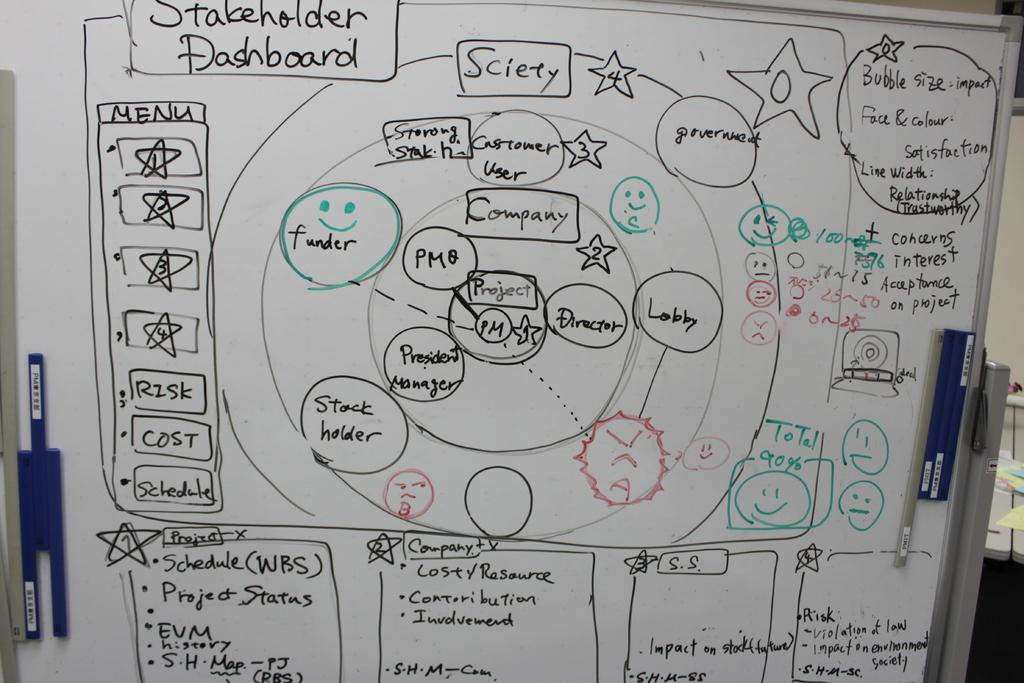<image>
Provide a brief description of the given image. A white board contains ideas for the stakeholder dashboard. 